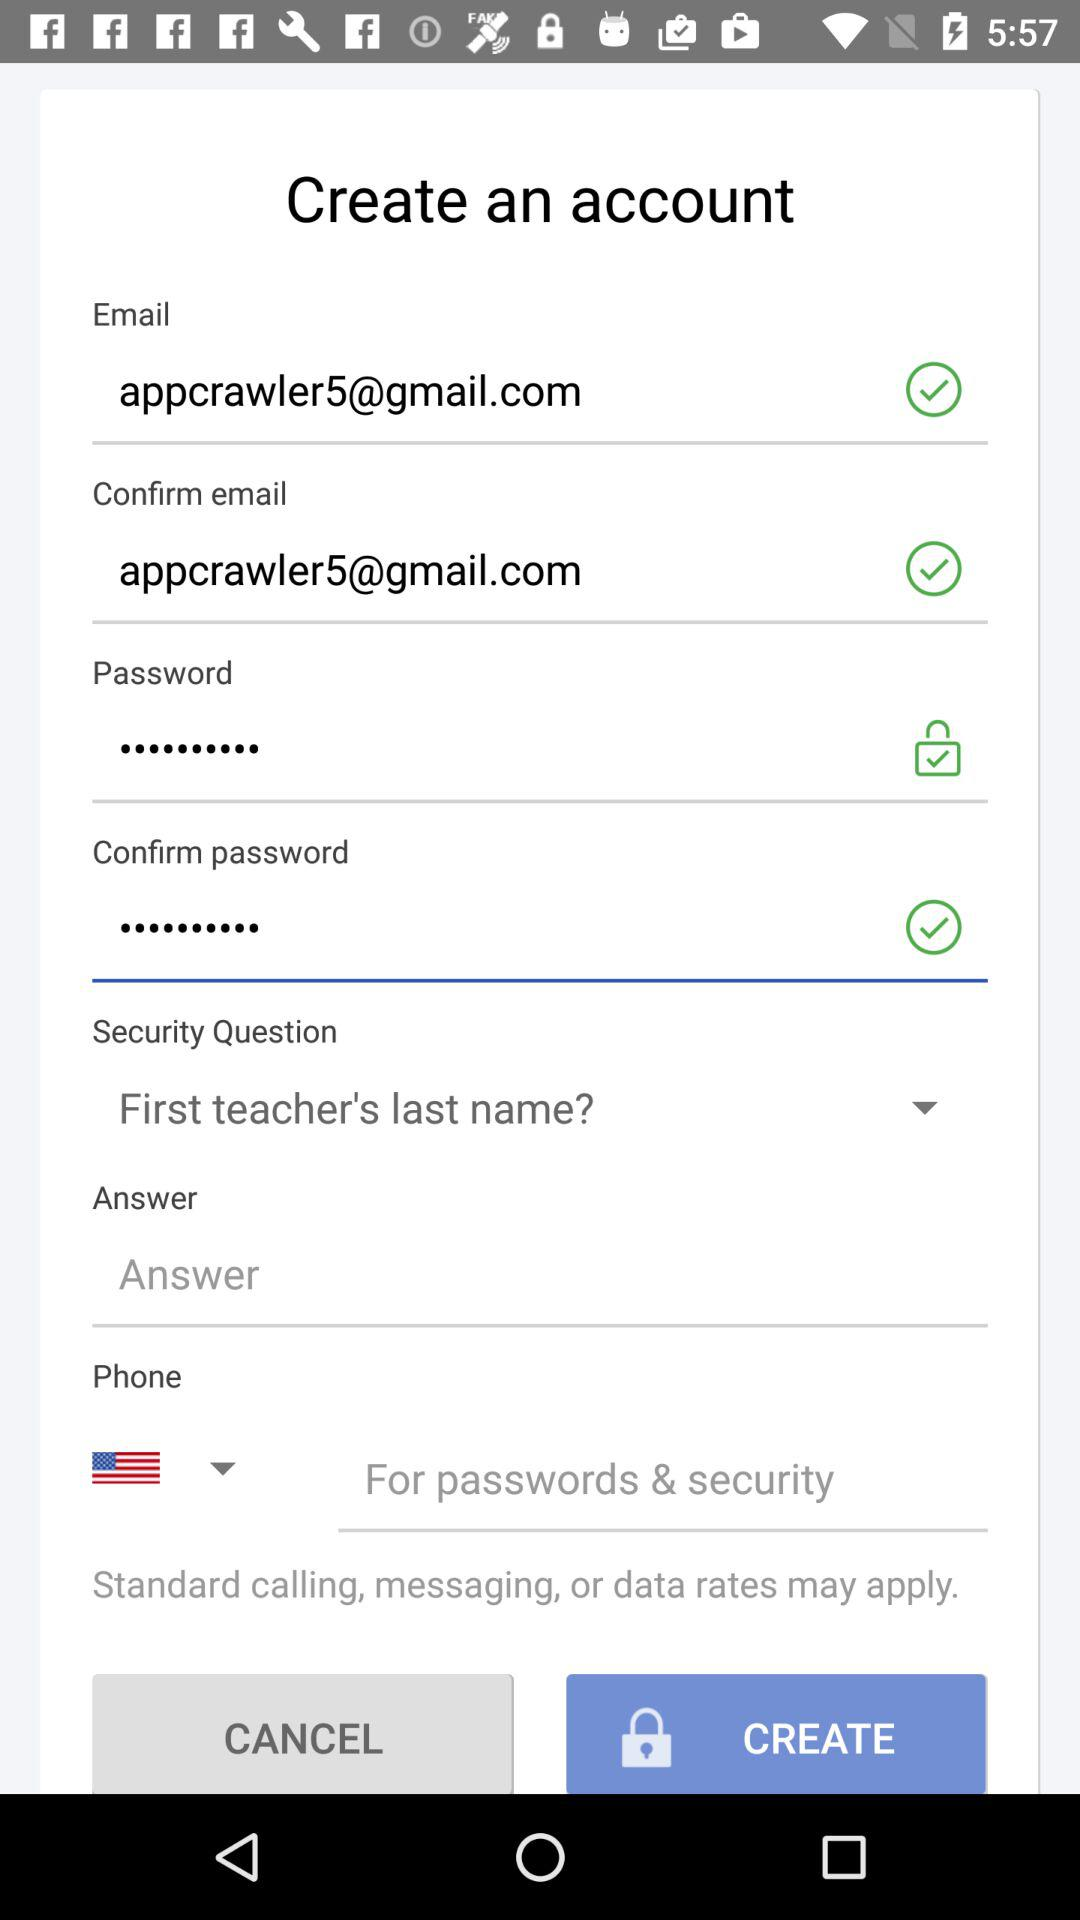What is the email address? The email address is appcrawler5@gmail.com. 